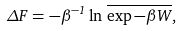<formula> <loc_0><loc_0><loc_500><loc_500>\Delta F = - \beta ^ { - 1 } \ln \, \overline { \exp - \beta W } ,</formula> 